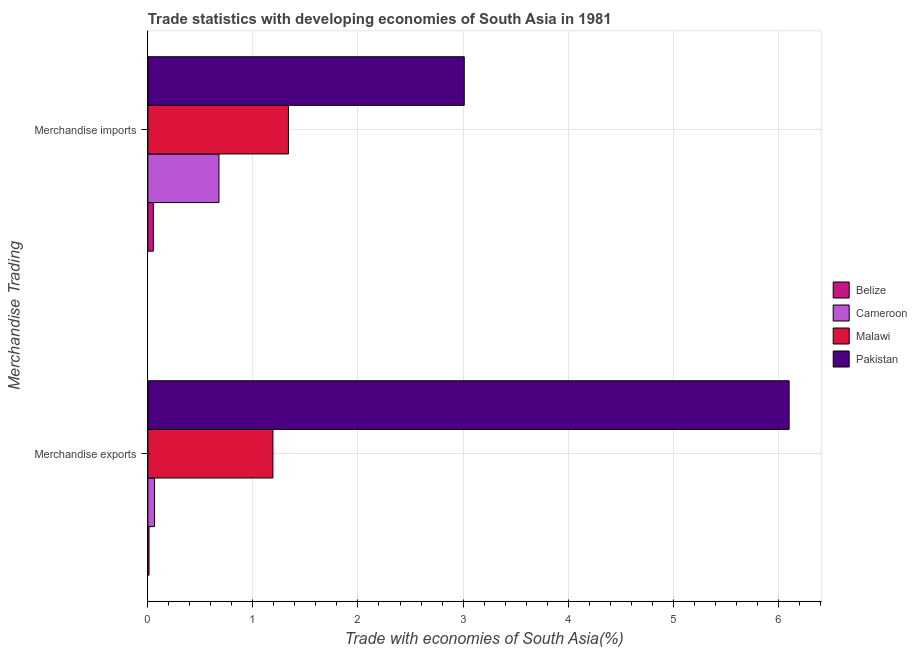How many groups of bars are there?
Provide a short and direct response. 2. Are the number of bars per tick equal to the number of legend labels?
Provide a succinct answer. Yes. Are the number of bars on each tick of the Y-axis equal?
Offer a very short reply. Yes. How many bars are there on the 2nd tick from the bottom?
Ensure brevity in your answer.  4. What is the label of the 2nd group of bars from the top?
Offer a terse response. Merchandise exports. What is the merchandise imports in Pakistan?
Keep it short and to the point. 3.01. Across all countries, what is the maximum merchandise imports?
Keep it short and to the point. 3.01. Across all countries, what is the minimum merchandise imports?
Your answer should be compact. 0.05. In which country was the merchandise imports minimum?
Ensure brevity in your answer.  Belize. What is the total merchandise exports in the graph?
Your response must be concise. 7.37. What is the difference between the merchandise exports in Cameroon and that in Malawi?
Make the answer very short. -1.13. What is the difference between the merchandise exports in Cameroon and the merchandise imports in Malawi?
Offer a very short reply. -1.27. What is the average merchandise imports per country?
Give a very brief answer. 1.27. What is the difference between the merchandise exports and merchandise imports in Belize?
Your response must be concise. -0.04. In how many countries, is the merchandise imports greater than 4.4 %?
Keep it short and to the point. 0. What is the ratio of the merchandise exports in Cameroon to that in Malawi?
Offer a very short reply. 0.05. In how many countries, is the merchandise exports greater than the average merchandise exports taken over all countries?
Ensure brevity in your answer.  1. What does the 4th bar from the top in Merchandise exports represents?
Your answer should be compact. Belize. What does the 2nd bar from the bottom in Merchandise imports represents?
Your answer should be very brief. Cameroon. How many countries are there in the graph?
Provide a short and direct response. 4. What is the difference between two consecutive major ticks on the X-axis?
Give a very brief answer. 1. Does the graph contain grids?
Provide a short and direct response. Yes. How are the legend labels stacked?
Your answer should be compact. Vertical. What is the title of the graph?
Offer a very short reply. Trade statistics with developing economies of South Asia in 1981. Does "World" appear as one of the legend labels in the graph?
Give a very brief answer. No. What is the label or title of the X-axis?
Give a very brief answer. Trade with economies of South Asia(%). What is the label or title of the Y-axis?
Offer a terse response. Merchandise Trading. What is the Trade with economies of South Asia(%) in Belize in Merchandise exports?
Offer a terse response. 0.01. What is the Trade with economies of South Asia(%) in Cameroon in Merchandise exports?
Provide a short and direct response. 0.06. What is the Trade with economies of South Asia(%) of Malawi in Merchandise exports?
Keep it short and to the point. 1.19. What is the Trade with economies of South Asia(%) in Pakistan in Merchandise exports?
Keep it short and to the point. 6.1. What is the Trade with economies of South Asia(%) of Belize in Merchandise imports?
Offer a very short reply. 0.05. What is the Trade with economies of South Asia(%) of Cameroon in Merchandise imports?
Your answer should be compact. 0.68. What is the Trade with economies of South Asia(%) in Malawi in Merchandise imports?
Your answer should be compact. 1.34. What is the Trade with economies of South Asia(%) of Pakistan in Merchandise imports?
Offer a terse response. 3.01. Across all Merchandise Trading, what is the maximum Trade with economies of South Asia(%) in Belize?
Give a very brief answer. 0.05. Across all Merchandise Trading, what is the maximum Trade with economies of South Asia(%) of Cameroon?
Your response must be concise. 0.68. Across all Merchandise Trading, what is the maximum Trade with economies of South Asia(%) of Malawi?
Give a very brief answer. 1.34. Across all Merchandise Trading, what is the maximum Trade with economies of South Asia(%) in Pakistan?
Provide a succinct answer. 6.1. Across all Merchandise Trading, what is the minimum Trade with economies of South Asia(%) of Belize?
Offer a terse response. 0.01. Across all Merchandise Trading, what is the minimum Trade with economies of South Asia(%) in Cameroon?
Your response must be concise. 0.06. Across all Merchandise Trading, what is the minimum Trade with economies of South Asia(%) of Malawi?
Provide a short and direct response. 1.19. Across all Merchandise Trading, what is the minimum Trade with economies of South Asia(%) in Pakistan?
Make the answer very short. 3.01. What is the total Trade with economies of South Asia(%) in Belize in the graph?
Offer a terse response. 0.06. What is the total Trade with economies of South Asia(%) in Cameroon in the graph?
Make the answer very short. 0.74. What is the total Trade with economies of South Asia(%) of Malawi in the graph?
Give a very brief answer. 2.53. What is the total Trade with economies of South Asia(%) of Pakistan in the graph?
Give a very brief answer. 9.12. What is the difference between the Trade with economies of South Asia(%) in Belize in Merchandise exports and that in Merchandise imports?
Offer a terse response. -0.04. What is the difference between the Trade with economies of South Asia(%) in Cameroon in Merchandise exports and that in Merchandise imports?
Give a very brief answer. -0.61. What is the difference between the Trade with economies of South Asia(%) in Malawi in Merchandise exports and that in Merchandise imports?
Give a very brief answer. -0.15. What is the difference between the Trade with economies of South Asia(%) of Pakistan in Merchandise exports and that in Merchandise imports?
Provide a short and direct response. 3.09. What is the difference between the Trade with economies of South Asia(%) in Belize in Merchandise exports and the Trade with economies of South Asia(%) in Cameroon in Merchandise imports?
Provide a succinct answer. -0.67. What is the difference between the Trade with economies of South Asia(%) in Belize in Merchandise exports and the Trade with economies of South Asia(%) in Malawi in Merchandise imports?
Provide a succinct answer. -1.33. What is the difference between the Trade with economies of South Asia(%) of Belize in Merchandise exports and the Trade with economies of South Asia(%) of Pakistan in Merchandise imports?
Provide a succinct answer. -3. What is the difference between the Trade with economies of South Asia(%) in Cameroon in Merchandise exports and the Trade with economies of South Asia(%) in Malawi in Merchandise imports?
Provide a short and direct response. -1.27. What is the difference between the Trade with economies of South Asia(%) of Cameroon in Merchandise exports and the Trade with economies of South Asia(%) of Pakistan in Merchandise imports?
Ensure brevity in your answer.  -2.95. What is the difference between the Trade with economies of South Asia(%) of Malawi in Merchandise exports and the Trade with economies of South Asia(%) of Pakistan in Merchandise imports?
Provide a short and direct response. -1.82. What is the average Trade with economies of South Asia(%) of Belize per Merchandise Trading?
Offer a terse response. 0.03. What is the average Trade with economies of South Asia(%) in Cameroon per Merchandise Trading?
Provide a short and direct response. 0.37. What is the average Trade with economies of South Asia(%) in Malawi per Merchandise Trading?
Offer a very short reply. 1.26. What is the average Trade with economies of South Asia(%) of Pakistan per Merchandise Trading?
Your response must be concise. 4.56. What is the difference between the Trade with economies of South Asia(%) in Belize and Trade with economies of South Asia(%) in Cameroon in Merchandise exports?
Offer a very short reply. -0.05. What is the difference between the Trade with economies of South Asia(%) of Belize and Trade with economies of South Asia(%) of Malawi in Merchandise exports?
Offer a terse response. -1.18. What is the difference between the Trade with economies of South Asia(%) of Belize and Trade with economies of South Asia(%) of Pakistan in Merchandise exports?
Provide a succinct answer. -6.09. What is the difference between the Trade with economies of South Asia(%) of Cameroon and Trade with economies of South Asia(%) of Malawi in Merchandise exports?
Your response must be concise. -1.13. What is the difference between the Trade with economies of South Asia(%) of Cameroon and Trade with economies of South Asia(%) of Pakistan in Merchandise exports?
Make the answer very short. -6.04. What is the difference between the Trade with economies of South Asia(%) of Malawi and Trade with economies of South Asia(%) of Pakistan in Merchandise exports?
Provide a short and direct response. -4.91. What is the difference between the Trade with economies of South Asia(%) of Belize and Trade with economies of South Asia(%) of Cameroon in Merchandise imports?
Ensure brevity in your answer.  -0.62. What is the difference between the Trade with economies of South Asia(%) of Belize and Trade with economies of South Asia(%) of Malawi in Merchandise imports?
Your answer should be very brief. -1.29. What is the difference between the Trade with economies of South Asia(%) of Belize and Trade with economies of South Asia(%) of Pakistan in Merchandise imports?
Make the answer very short. -2.96. What is the difference between the Trade with economies of South Asia(%) of Cameroon and Trade with economies of South Asia(%) of Malawi in Merchandise imports?
Provide a succinct answer. -0.66. What is the difference between the Trade with economies of South Asia(%) of Cameroon and Trade with economies of South Asia(%) of Pakistan in Merchandise imports?
Keep it short and to the point. -2.33. What is the difference between the Trade with economies of South Asia(%) of Malawi and Trade with economies of South Asia(%) of Pakistan in Merchandise imports?
Keep it short and to the point. -1.67. What is the ratio of the Trade with economies of South Asia(%) in Belize in Merchandise exports to that in Merchandise imports?
Offer a very short reply. 0.21. What is the ratio of the Trade with economies of South Asia(%) of Cameroon in Merchandise exports to that in Merchandise imports?
Give a very brief answer. 0.09. What is the ratio of the Trade with economies of South Asia(%) of Malawi in Merchandise exports to that in Merchandise imports?
Ensure brevity in your answer.  0.89. What is the ratio of the Trade with economies of South Asia(%) in Pakistan in Merchandise exports to that in Merchandise imports?
Keep it short and to the point. 2.03. What is the difference between the highest and the second highest Trade with economies of South Asia(%) of Belize?
Offer a terse response. 0.04. What is the difference between the highest and the second highest Trade with economies of South Asia(%) in Cameroon?
Your answer should be compact. 0.61. What is the difference between the highest and the second highest Trade with economies of South Asia(%) of Malawi?
Ensure brevity in your answer.  0.15. What is the difference between the highest and the second highest Trade with economies of South Asia(%) in Pakistan?
Your answer should be compact. 3.09. What is the difference between the highest and the lowest Trade with economies of South Asia(%) in Belize?
Provide a short and direct response. 0.04. What is the difference between the highest and the lowest Trade with economies of South Asia(%) in Cameroon?
Ensure brevity in your answer.  0.61. What is the difference between the highest and the lowest Trade with economies of South Asia(%) in Malawi?
Your response must be concise. 0.15. What is the difference between the highest and the lowest Trade with economies of South Asia(%) in Pakistan?
Ensure brevity in your answer.  3.09. 